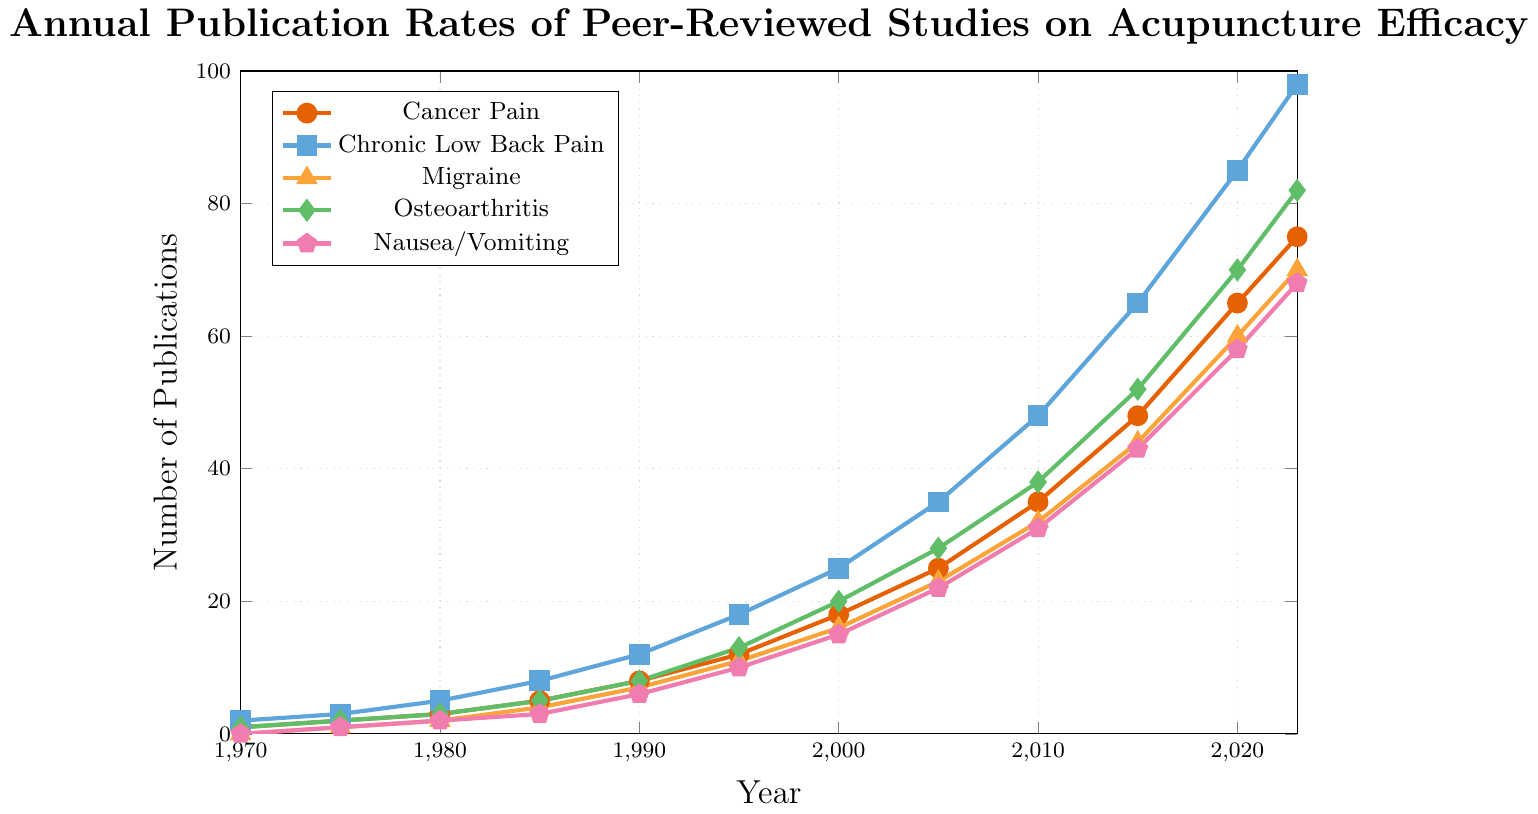What was the publication rate for Chronic Low Back Pain in 2010? First, locate the year 2010 on the X-axis. Then find the corresponding point for the Chronic Low Back Pain line, which is marked with squares. The value is at 48.
Answer: 48 In which year did Cancer Pain publications first exceed 10 annually? Look at the Cancer Pain line marked with circles. Check where the point first exceeds 10 on the Y-axis. This occurs in 1995 with a value of 12.
Answer: 1995 How does the publication rate for Migraine in 2023 compare to that for Osteoarthritis in 2005? For Migraine, find the value in 2023 (70) on the triangle-marked line. For Osteoarthritis, find the value in 2005 (28) on the diamond-marked line. Migraine in 2023 (70) is greater than Osteoarthritis in 2005 (28).
Answer: Migraine is greater What is the total number of publications for Nausea/Vomiting from 1970 to 1985? Sum the values for Nausea/Vomiting for the years 1970 (0), 1975 (1), 1980 (2), and 1985 (3). The total is 0 + 1 + 2 + 3 = 6.
Answer: 6 Which condition shows the highest publication rate in 2020? Check the 2020 values for all lines. Cancer Pain: 65, Chronic Low Back Pain: 85, Migraine: 60, Osteoarthritis: 70, Nausea/Vomiting: 58. Chronic Low Back Pain (85) is the highest.
Answer: Chronic Low Back Pain How many more publications were there for Chronic Low Back Pain in 2023 compared to Cancer Pain in 2023? Find the 2023 value for Chronic Low Back Pain (98) and Cancer Pain (75). Calculate the difference, 98 - 75 = 23.
Answer: 23 In which year did the number of publications for Osteoarthritis first reach at least 20? Locate the point on the Osteoarthritis line (diamond-marked) that first equals or exceeds 20. This occurs in 2000.
Answer: 2000 For Cancer Pain and Nausea/Vomiting, how much did the publication rate increase from 1970 to 2023? Calculate the difference for Cancer Pain: 1970 (1) to 2023 (75), 75 - 1 = 74. For Nausea/Vomiting: 1970 (0) to 2023 (68), 68 - 0 = 68.
Answer: Cancer Pain: 74, Nausea/Vomiting: 68 Which condition had the smallest increase in publication rate from 2015 to 2020? Check the values in 2015 and 2020. Cancer Pain: 48 to 65 (17), Chronic Low Back Pain: 65 to 85 (20), Migraine: 44 to 60 (16), Osteoarthritis: 52 to 70 (18), Nausea/Vomiting: 43 to 58 (15). Migraine's increase (16) is the smallest.
Answer: Migraine 